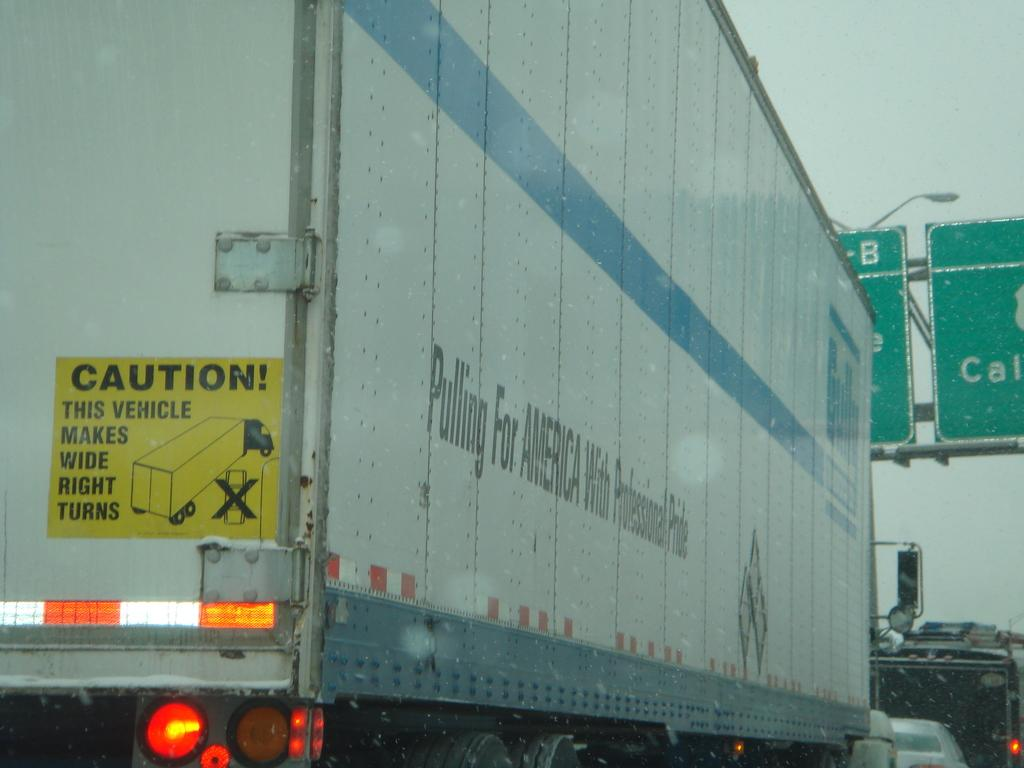What is the main subject of the image? A: The main subject of the image is a truck moving on the road. What other vehicle can be seen in the image? There is a vehicle at the bottom right of the image. What is located on the right side of the image? There is a boat in green color on the right side of the image. What is visible at the top of the image? The sky is visible at the top of the image. Where is the faucet located in the image? There is no faucet present in the image. Can you describe the girl in the image? There is no girl present in the image. 